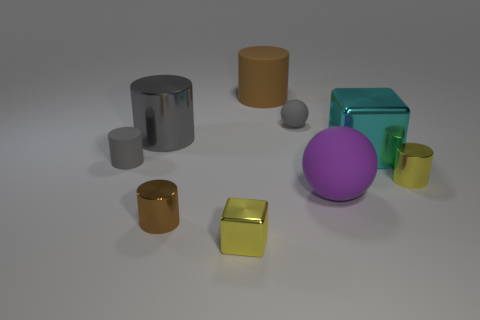Subtract all yellow cylinders. How many cylinders are left? 4 Subtract 2 cylinders. How many cylinders are left? 3 Subtract all brown matte cylinders. How many cylinders are left? 4 Subtract all red cylinders. Subtract all purple cubes. How many cylinders are left? 5 Add 1 tiny shiny things. How many objects exist? 10 Subtract all balls. How many objects are left? 7 Subtract all tiny blue shiny things. Subtract all metal blocks. How many objects are left? 7 Add 3 gray matte things. How many gray matte things are left? 5 Add 4 tiny red balls. How many tiny red balls exist? 4 Subtract 0 blue cylinders. How many objects are left? 9 